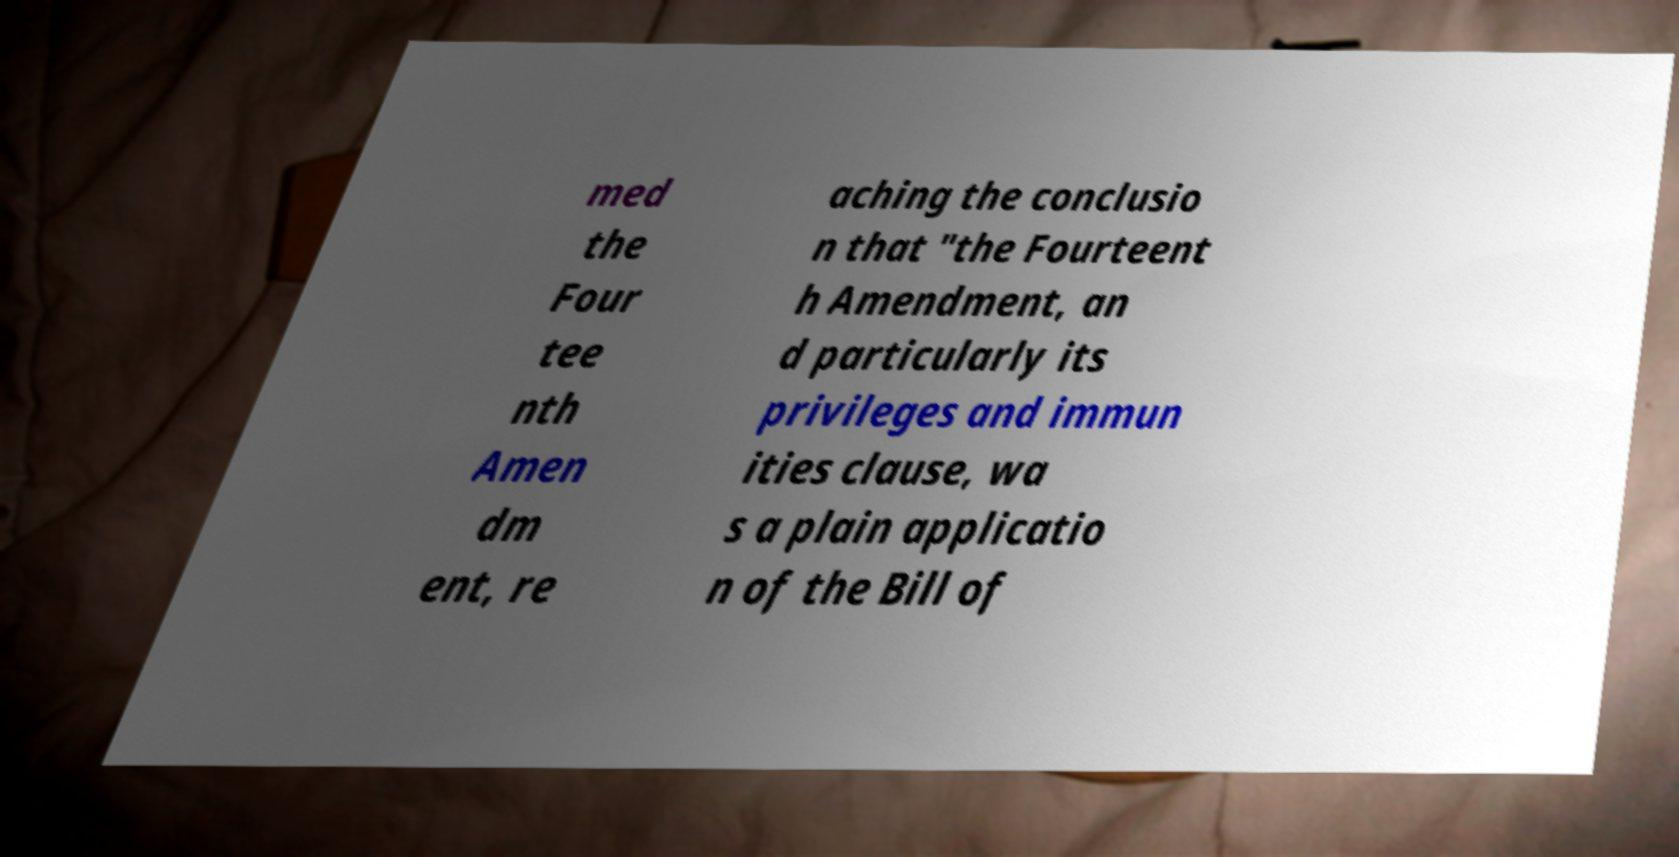There's text embedded in this image that I need extracted. Can you transcribe it verbatim? med the Four tee nth Amen dm ent, re aching the conclusio n that "the Fourteent h Amendment, an d particularly its privileges and immun ities clause, wa s a plain applicatio n of the Bill of 